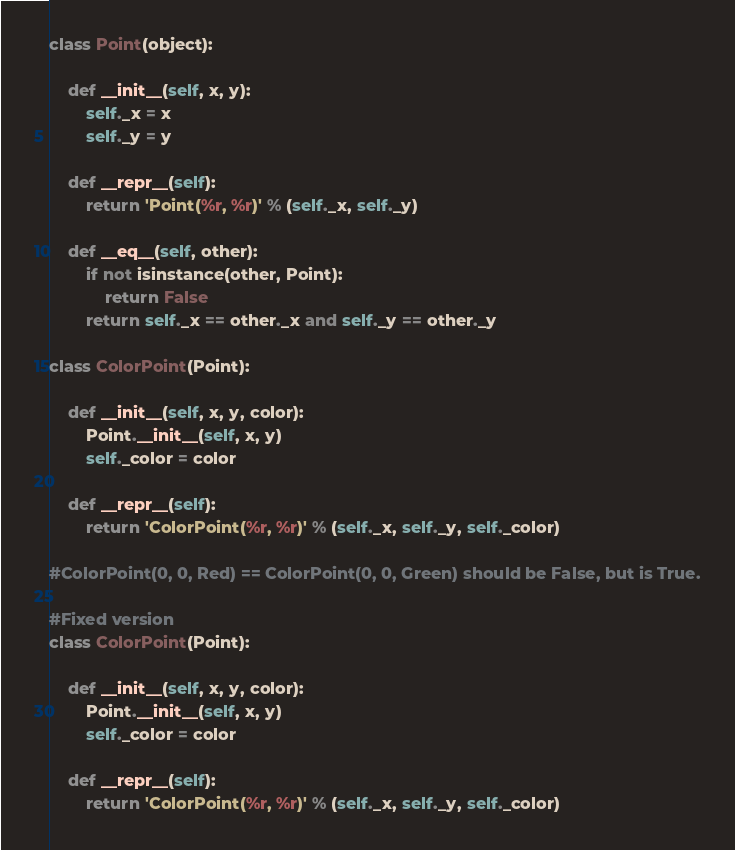Convert code to text. <code><loc_0><loc_0><loc_500><loc_500><_Python_>class Point(object):

    def __init__(self, x, y):
        self._x = x
        self._y = y

    def __repr__(self):
        return 'Point(%r, %r)' % (self._x, self._y)

    def __eq__(self, other):
        if not isinstance(other, Point):
            return False
        return self._x == other._x and self._y == other._y

class ColorPoint(Point):

    def __init__(self, x, y, color):
        Point.__init__(self, x, y)
        self._color = color

    def __repr__(self):
        return 'ColorPoint(%r, %r)' % (self._x, self._y, self._color)

#ColorPoint(0, 0, Red) == ColorPoint(0, 0, Green) should be False, but is True.

#Fixed version
class ColorPoint(Point):

    def __init__(self, x, y, color):
        Point.__init__(self, x, y)
        self._color = color

    def __repr__(self):
        return 'ColorPoint(%r, %r)' % (self._x, self._y, self._color)
</code> 